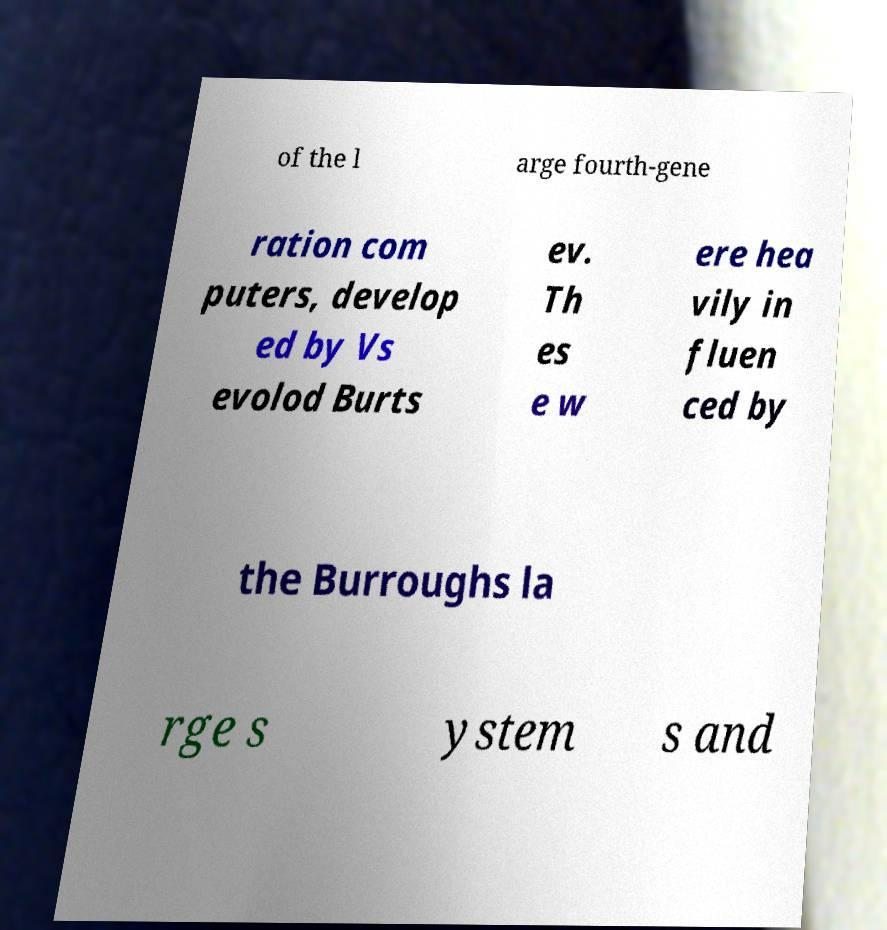Please read and relay the text visible in this image. What does it say? of the l arge fourth-gene ration com puters, develop ed by Vs evolod Burts ev. Th es e w ere hea vily in fluen ced by the Burroughs la rge s ystem s and 